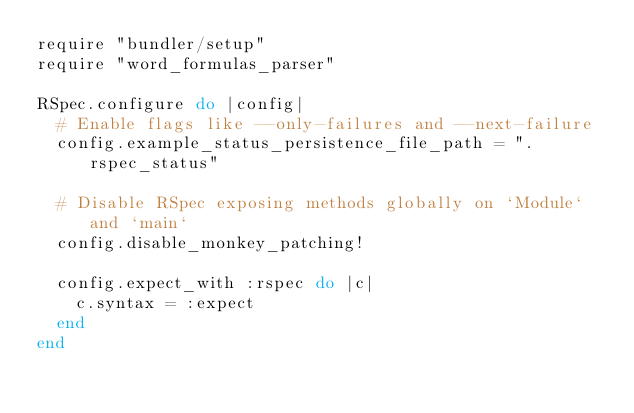<code> <loc_0><loc_0><loc_500><loc_500><_Ruby_>require "bundler/setup"
require "word_formulas_parser"

RSpec.configure do |config|
  # Enable flags like --only-failures and --next-failure
  config.example_status_persistence_file_path = ".rspec_status"

  # Disable RSpec exposing methods globally on `Module` and `main`
  config.disable_monkey_patching!

  config.expect_with :rspec do |c|
    c.syntax = :expect
  end
end
</code> 